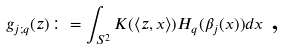Convert formula to latex. <formula><loc_0><loc_0><loc_500><loc_500>g _ { j ; q } ( z ) \colon = \int _ { S ^ { 2 } } K ( \left \langle z , x \right \rangle ) H _ { q } ( \beta _ { j } ( x ) ) d x \text { ,}</formula> 